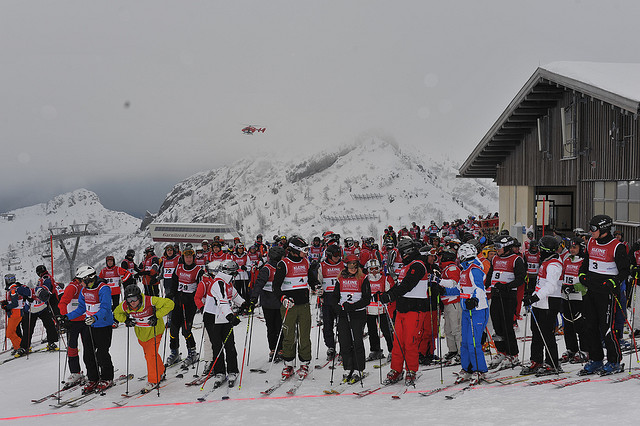Extract all visible text content from this image. 15 3 9 2 20 12 4 11 